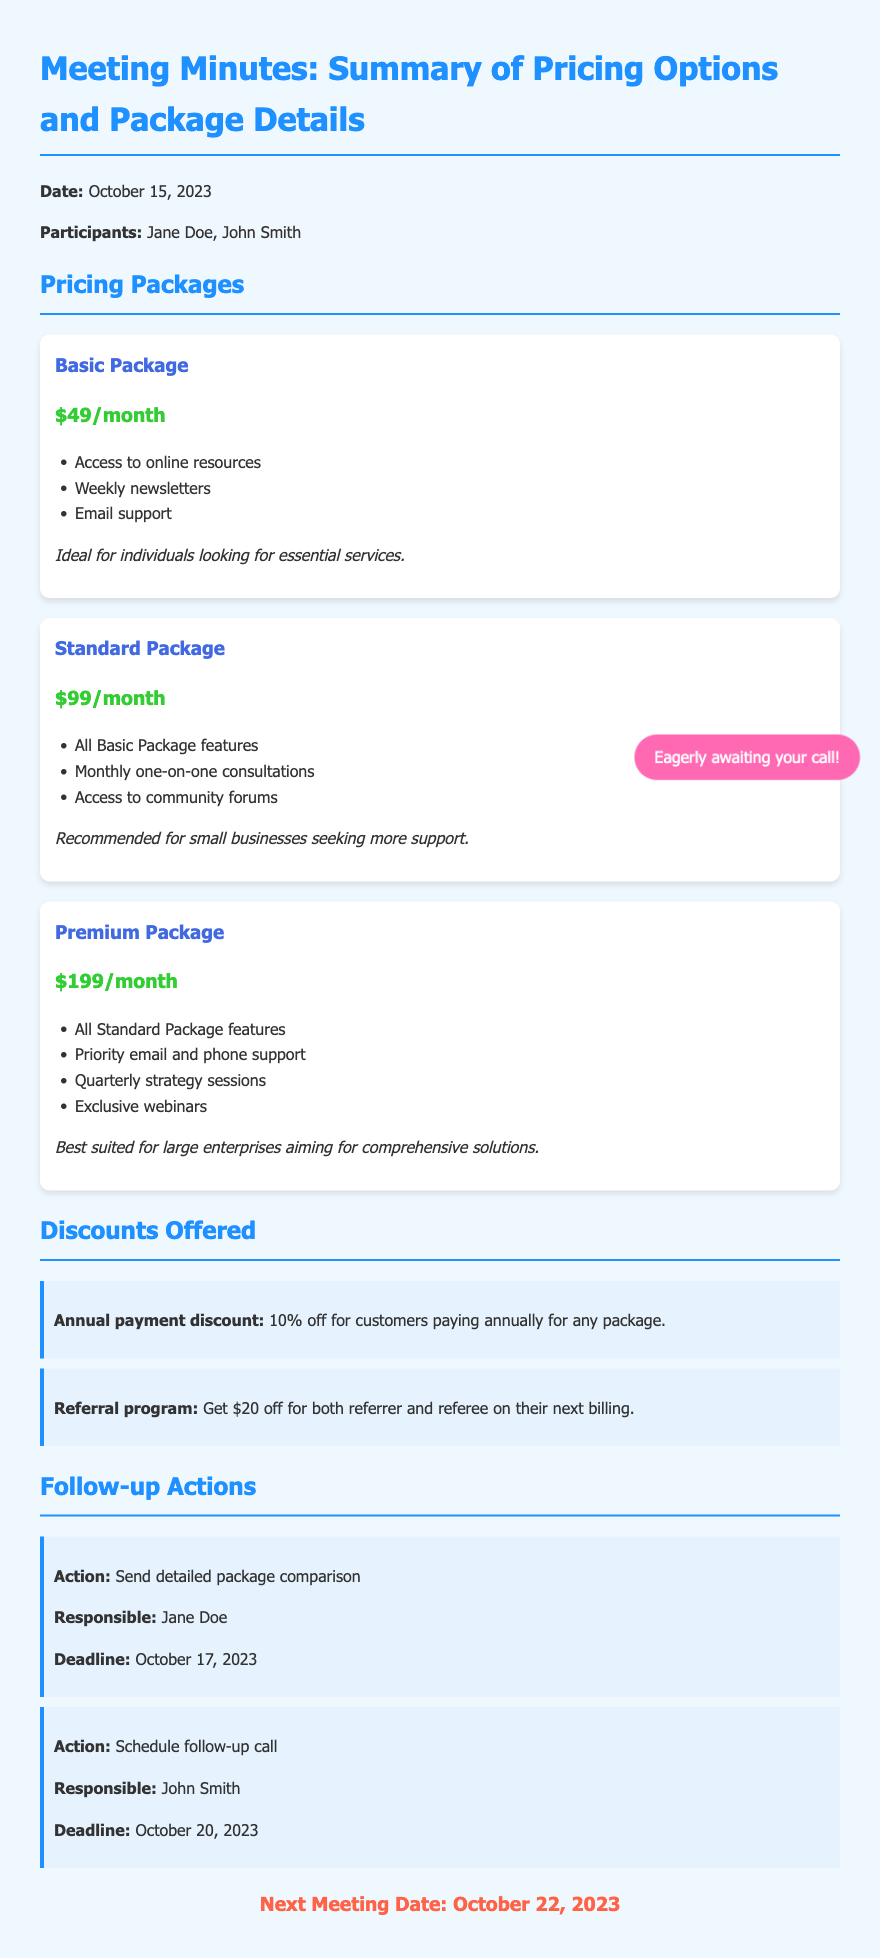What is the date of the meeting? The date of the meeting is stated at the beginning of the document.
Answer: October 15, 2023 Who is responsible for sending the detailed package comparison? The document lists the responsible person for each action item, including sending the package comparison.
Answer: Jane Doe What is the price of the Premium Package? The document specifies the pricing for each package under the Pricing Packages section.
Answer: $199/month What discount is offered for annual payment? The document mentions the specific discount for annual payments in the Discounts Offered section.
Answer: 10% off How many packages are discussed in the meeting? The total number of packages can be counted based on the document's sections about Pricing Packages.
Answer: Three Which package includes access to community forums? The access to community forums is mentioned under the features of a specific package in the document.
Answer: Standard Package What is the deadline for scheduling the follow-up call? The deadline for each action is clearly mentioned in the Follow-up Actions section.
Answer: October 20, 2023 What is the next meeting date? The date for the next meeting is provided at the end of the document.
Answer: October 22, 2023 What is the referral program discount? The document describes the referral program's benefits, detailing the discount offered.
Answer: $20 off 